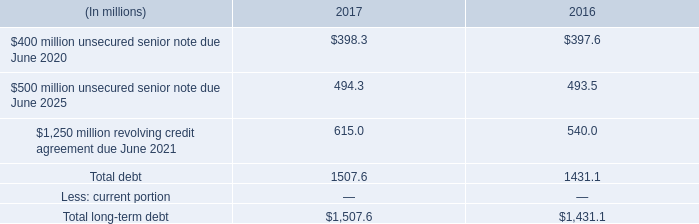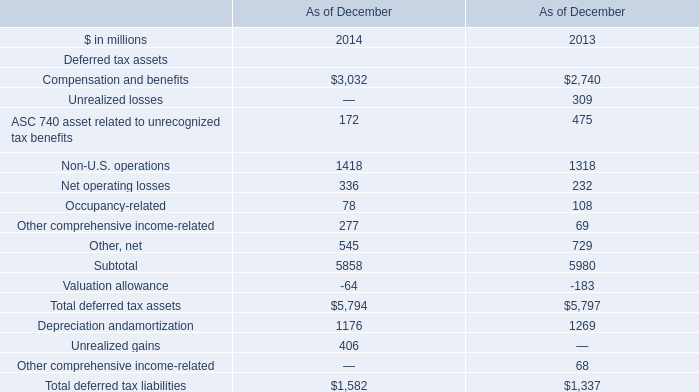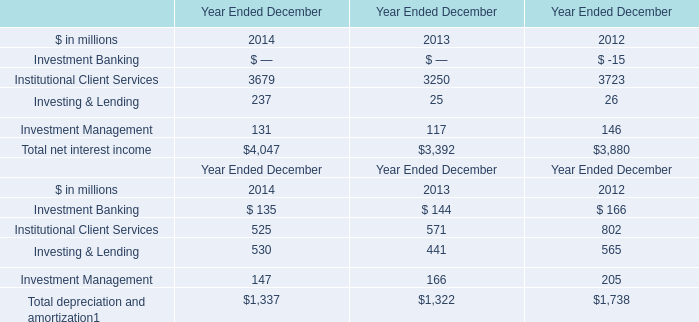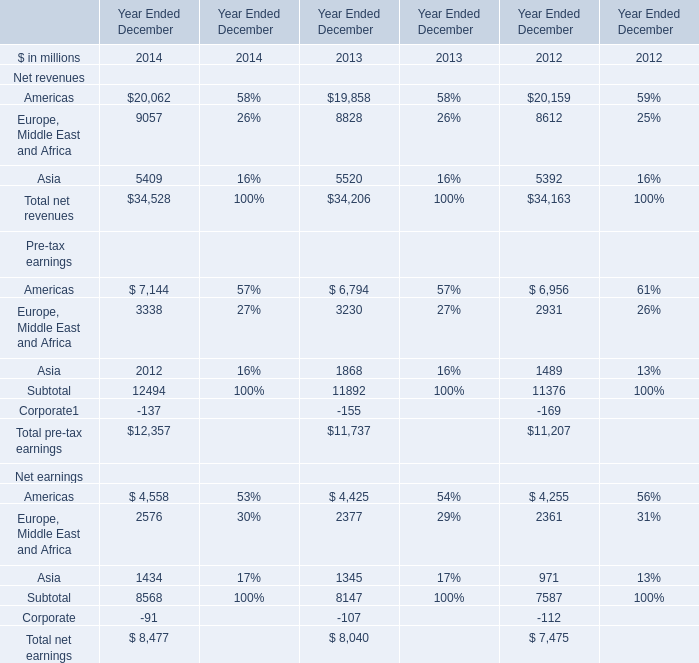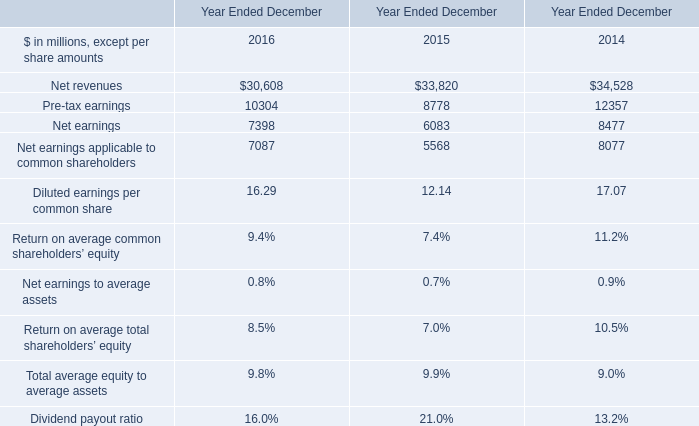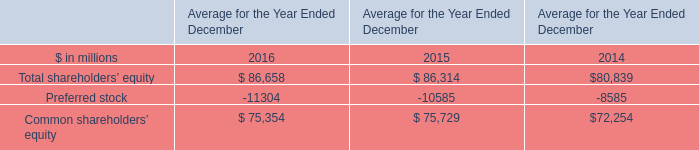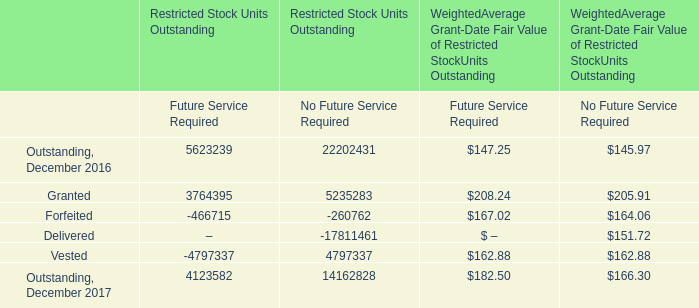Which element occupies the greatest proportion in total amount in 2014 forYear Ended December ? 
Answer: Total net interest income. 